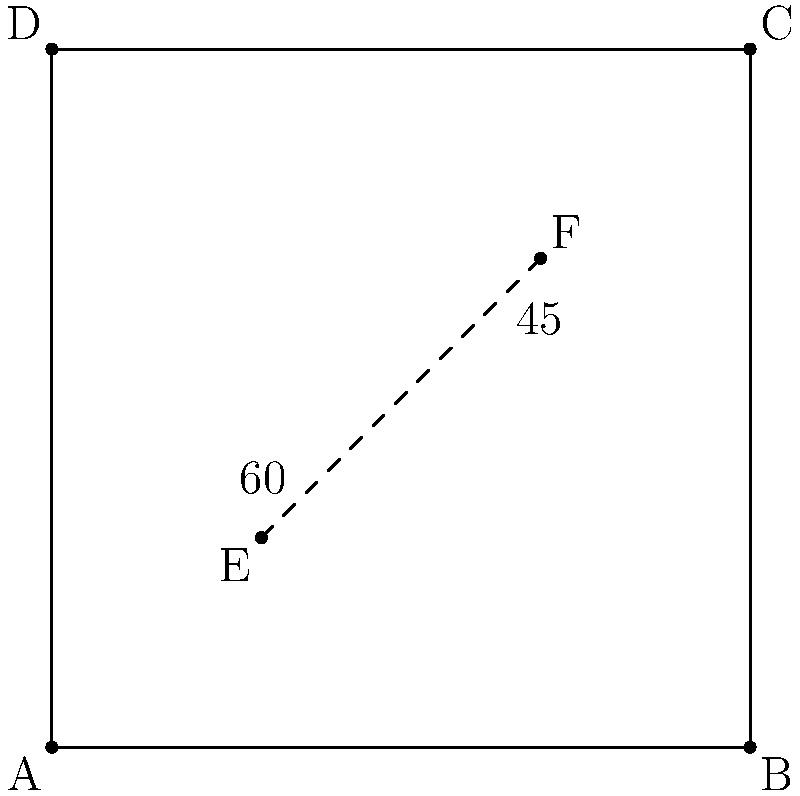In a top-down view of a competitive gaming map, two players are positioned at points E and F on a square battlefield ABCD. Player E has a line of sight at a 60° angle, while player F has a 45° angle. If the battlefield is 100 units wide, what is the minimum distance between the two players for them to have an unobstructed view of each other? To solve this problem, we'll follow these steps:

1) First, we need to determine the coordinates of points E and F. From the diagram, we can see that E is at (30,30) and F is at (70,70).

2) The distance between two points can be calculated using the distance formula:
   $$d = \sqrt{(x_2-x_1)^2 + (y_2-y_1)^2}$$

3) Plugging in the coordinates:
   $$d = \sqrt{(70-30)^2 + (70-30)^2}$$

4) Simplify:
   $$d = \sqrt{40^2 + 40^2} = \sqrt{1600 + 1600} = \sqrt{3200}$$

5) Simplify further:
   $$d = 40\sqrt{2}$$

6) This distance is in the same units as the battlefield width. Since the battlefield is 100 units wide, we can express this as a percentage:
   $$\frac{40\sqrt{2}}{100} \times 100\% = 40\sqrt{2}\% \approx 56.57\%$$

Therefore, the minimum distance between the two players for an unobstructed view is $40\sqrt{2}$ units, or approximately 56.57% of the battlefield width.
Answer: $40\sqrt{2}$ units (or 56.57% of battlefield width) 